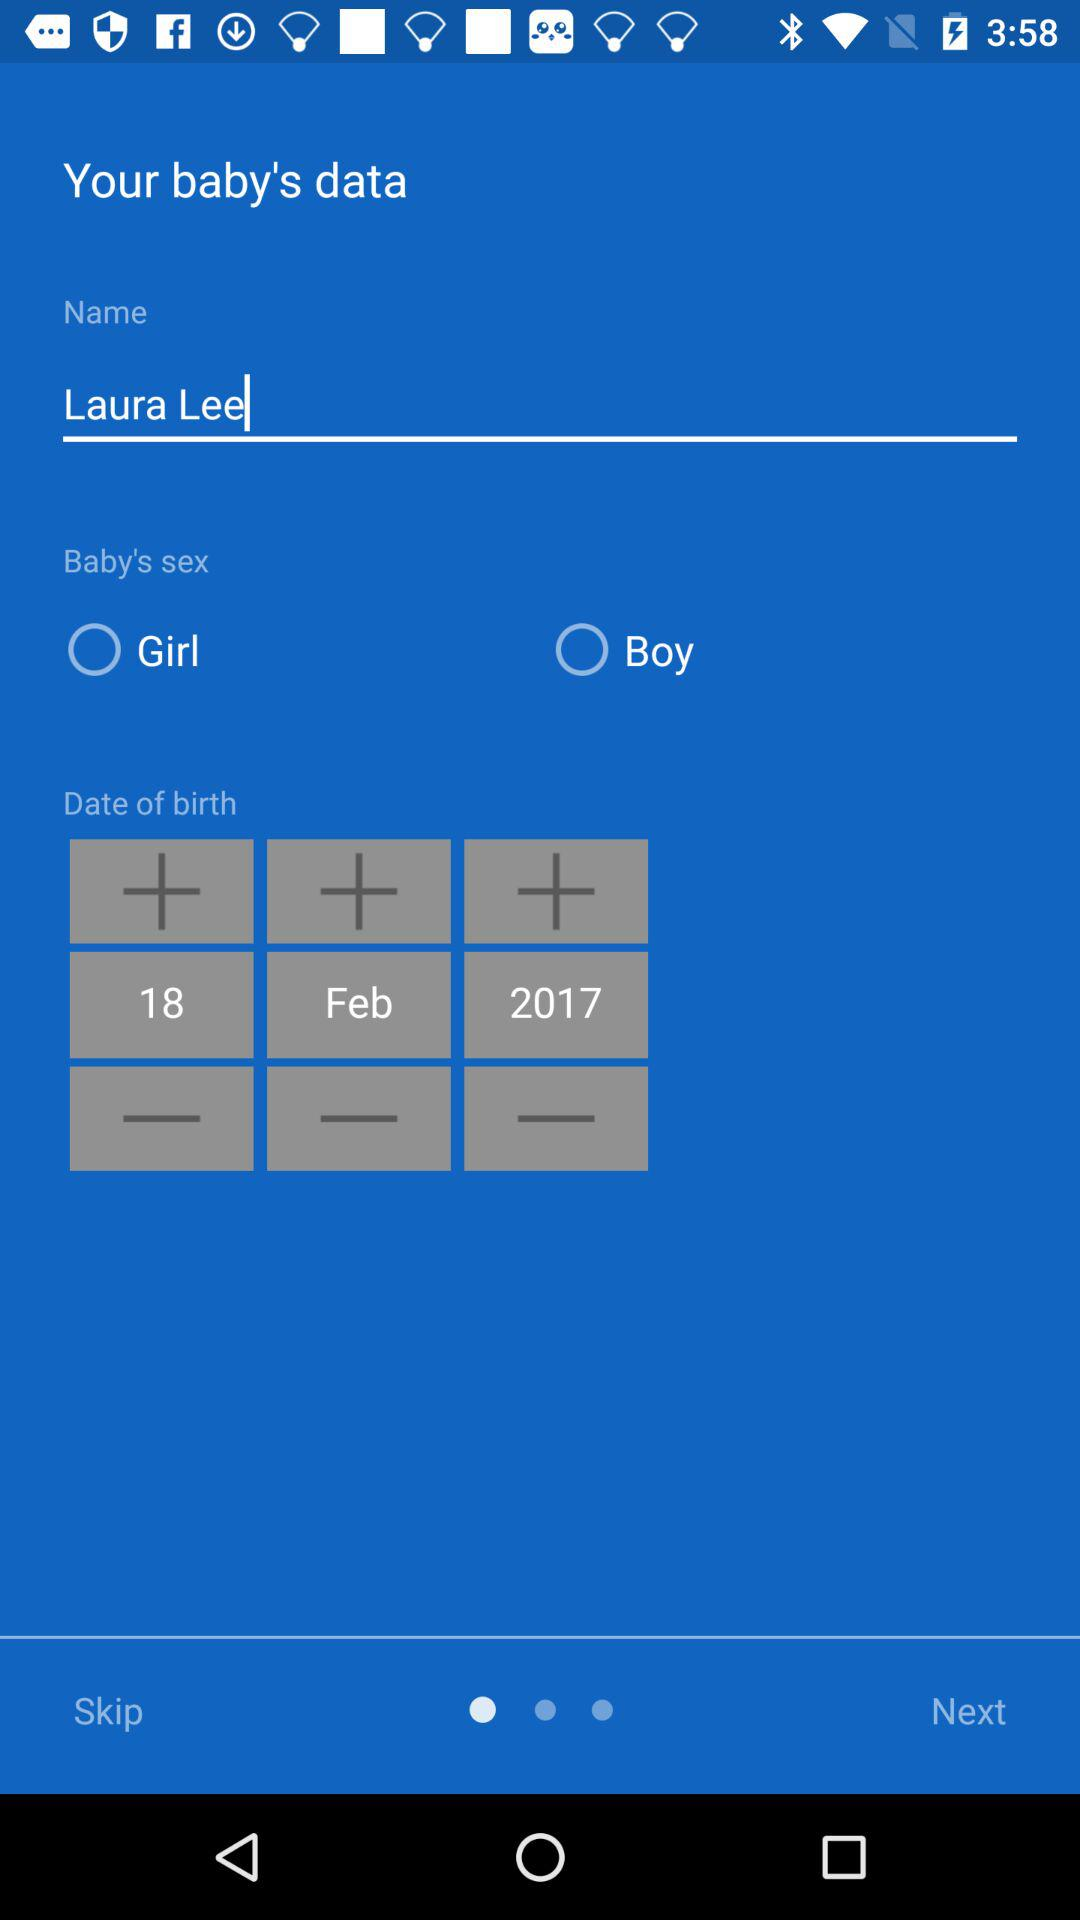What is the name of the baby? The name of the baby is Laura Lee. 